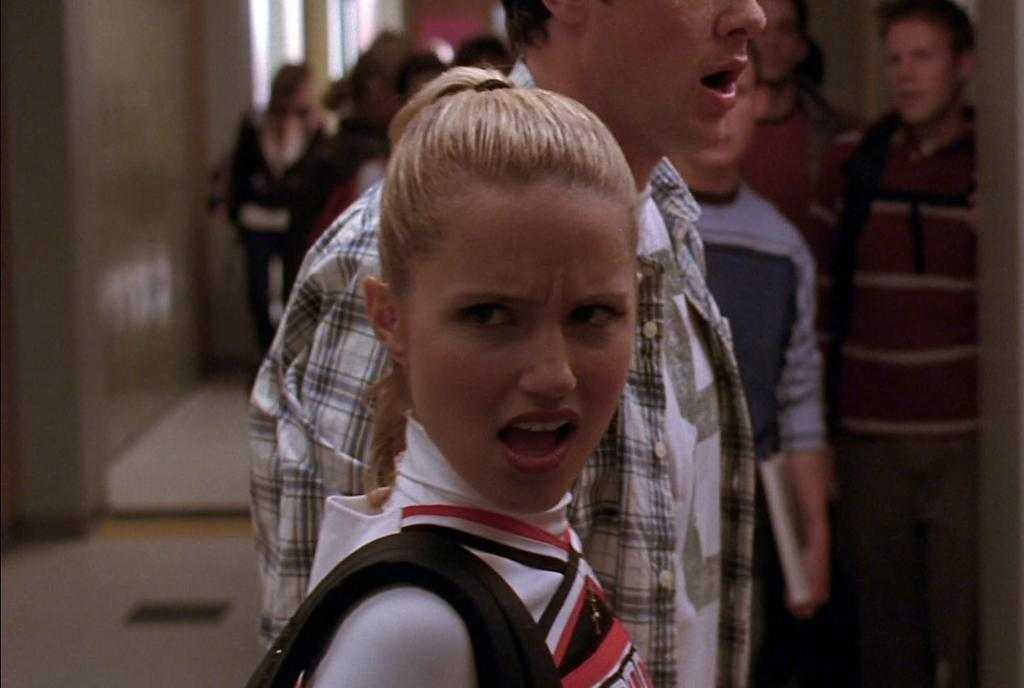Who is the main subject in the image? There is a girl in the image. What can be seen in the background of the image? There is a group of people, a wall, and some objects in the background of the image. What time of day is it in the image? The time of day cannot be determined from the image, as there are no clues or indicators present. 